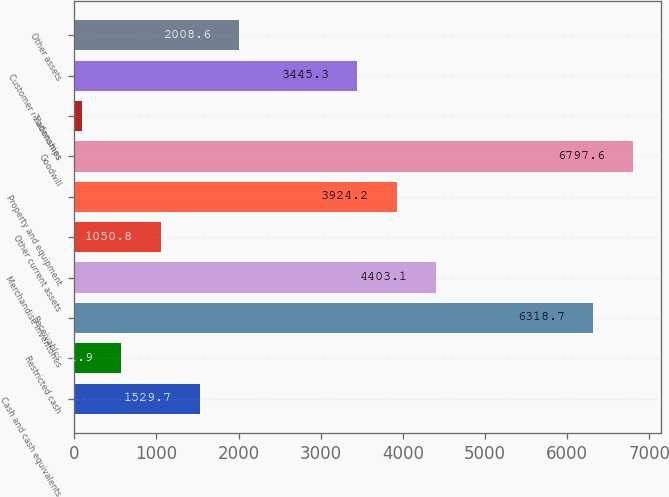<chart> <loc_0><loc_0><loc_500><loc_500><bar_chart><fcel>Cash and cash equivalents<fcel>Restricted cash<fcel>Receivables<fcel>Merchandise inventories<fcel>Other current assets<fcel>Property and equipment<fcel>Goodwill<fcel>Tradenames<fcel>Customer relationships<fcel>Other assets<nl><fcel>1529.7<fcel>571.9<fcel>6318.7<fcel>4403.1<fcel>1050.8<fcel>3924.2<fcel>6797.6<fcel>93<fcel>3445.3<fcel>2008.6<nl></chart> 